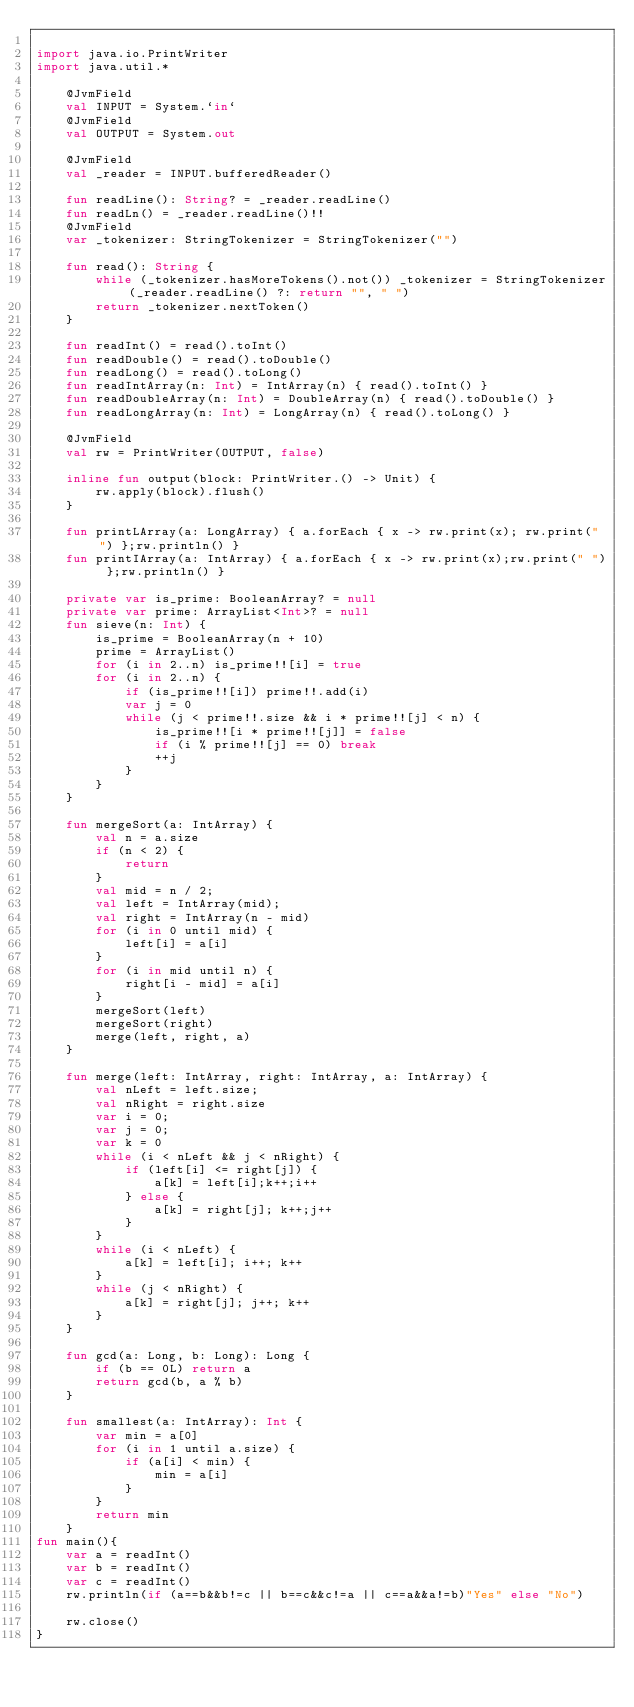<code> <loc_0><loc_0><loc_500><loc_500><_Kotlin_>
import java.io.PrintWriter
import java.util.*

    @JvmField
    val INPUT = System.`in`
    @JvmField
    val OUTPUT = System.out

    @JvmField
    val _reader = INPUT.bufferedReader()

    fun readLine(): String? = _reader.readLine()
    fun readLn() = _reader.readLine()!!
    @JvmField
    var _tokenizer: StringTokenizer = StringTokenizer("")

    fun read(): String {
        while (_tokenizer.hasMoreTokens().not()) _tokenizer = StringTokenizer(_reader.readLine() ?: return "", " ")
        return _tokenizer.nextToken()
    }

    fun readInt() = read().toInt()
    fun readDouble() = read().toDouble()
    fun readLong() = read().toLong()
    fun readIntArray(n: Int) = IntArray(n) { read().toInt() }
    fun readDoubleArray(n: Int) = DoubleArray(n) { read().toDouble() }
    fun readLongArray(n: Int) = LongArray(n) { read().toLong() }

    @JvmField
    val rw = PrintWriter(OUTPUT, false)

    inline fun output(block: PrintWriter.() -> Unit) {
        rw.apply(block).flush()
    }

    fun printLArray(a: LongArray) { a.forEach { x -> rw.print(x); rw.print(" ") };rw.println() }
    fun printIArray(a: IntArray) { a.forEach { x -> rw.print(x);rw.print(" ") };rw.println() }

    private var is_prime: BooleanArray? = null
    private var prime: ArrayList<Int>? = null
    fun sieve(n: Int) {
        is_prime = BooleanArray(n + 10)
        prime = ArrayList()
        for (i in 2..n) is_prime!![i] = true
        for (i in 2..n) {
            if (is_prime!![i]) prime!!.add(i)
            var j = 0
            while (j < prime!!.size && i * prime!![j] < n) {
                is_prime!![i * prime!![j]] = false
                if (i % prime!![j] == 0) break
                ++j
            }
        }
    }

    fun mergeSort(a: IntArray) {
        val n = a.size
        if (n < 2) {
            return
        }
        val mid = n / 2;
        val left = IntArray(mid);
        val right = IntArray(n - mid)
        for (i in 0 until mid) {
            left[i] = a[i]
        }
        for (i in mid until n) {
            right[i - mid] = a[i]
        }
        mergeSort(left)
        mergeSort(right)
        merge(left, right, a)
    }

    fun merge(left: IntArray, right: IntArray, a: IntArray) {
        val nLeft = left.size;
        val nRight = right.size
        var i = 0;
        var j = 0;
        var k = 0
        while (i < nLeft && j < nRight) {
            if (left[i] <= right[j]) {
                a[k] = left[i];k++;i++
            } else {
                a[k] = right[j]; k++;j++
            }
        }
        while (i < nLeft) {
            a[k] = left[i]; i++; k++
        }
        while (j < nRight) {
            a[k] = right[j]; j++; k++
        }
    }

    fun gcd(a: Long, b: Long): Long {
        if (b == 0L) return a
        return gcd(b, a % b)
    }

    fun smallest(a: IntArray): Int {
        var min = a[0]
        for (i in 1 until a.size) {
            if (a[i] < min) {
                min = a[i]
            }
        }
        return min
    }
fun main(){
    var a = readInt()
    var b = readInt()
    var c = readInt()
    rw.println(if (a==b&&b!=c || b==c&&c!=a || c==a&&a!=b)"Yes" else "No")

    rw.close()
}</code> 